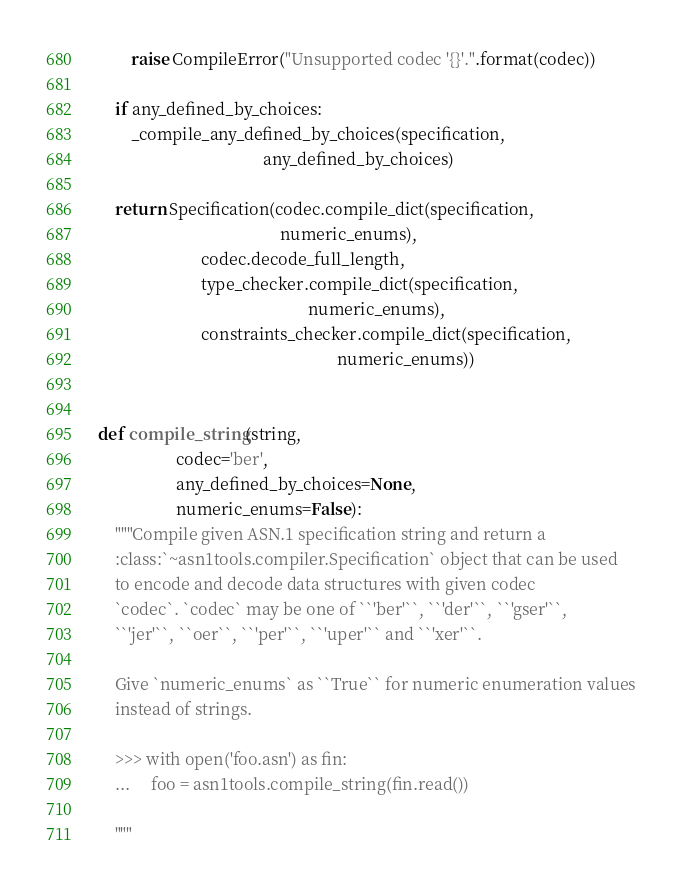<code> <loc_0><loc_0><loc_500><loc_500><_Python_>        raise CompileError("Unsupported codec '{}'.".format(codec))

    if any_defined_by_choices:
        _compile_any_defined_by_choices(specification,
                                        any_defined_by_choices)

    return Specification(codec.compile_dict(specification,
                                            numeric_enums),
                         codec.decode_full_length,
                         type_checker.compile_dict(specification,
                                                   numeric_enums),
                         constraints_checker.compile_dict(specification,
                                                          numeric_enums))


def compile_string(string,
                   codec='ber',
                   any_defined_by_choices=None,
                   numeric_enums=False):
    """Compile given ASN.1 specification string and return a
    :class:`~asn1tools.compiler.Specification` object that can be used
    to encode and decode data structures with given codec
    `codec`. `codec` may be one of ``'ber'``, ``'der'``, ``'gser'``,
    ``'jer'``, ``oer``, ``'per'``, ``'uper'`` and ``'xer'``.

    Give `numeric_enums` as ``True`` for numeric enumeration values
    instead of strings.

    >>> with open('foo.asn') as fin:
    ...     foo = asn1tools.compile_string(fin.read())

    """
</code> 